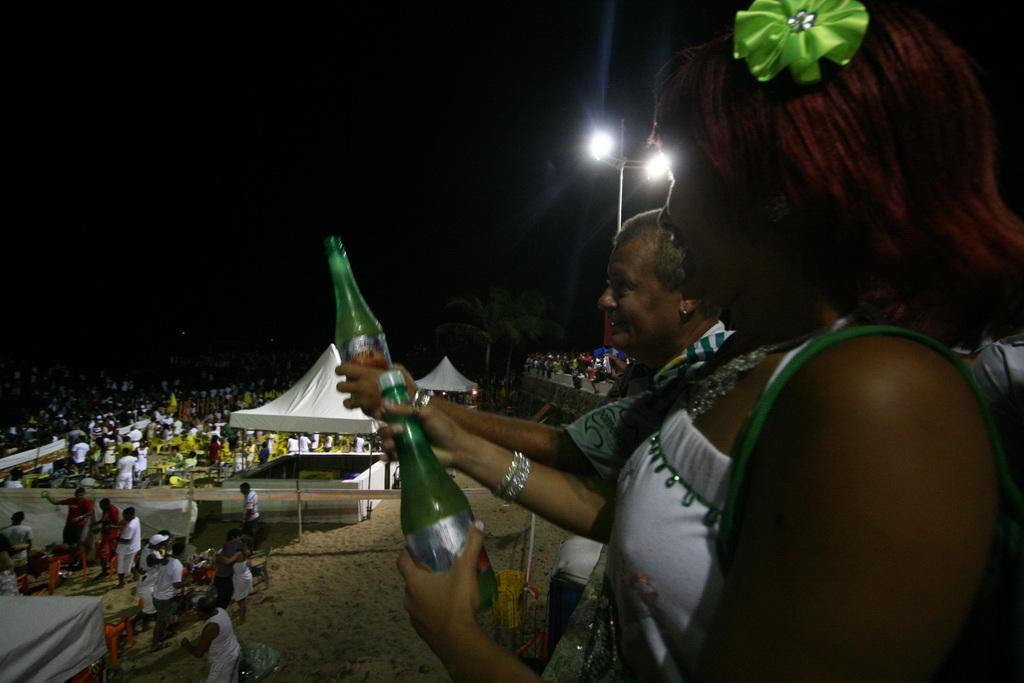Can you describe this image briefly? In the picture we can see there are many people. this is a tent, light pole, tree. This people are holding bottle in their hand. The sand is in cream color. 